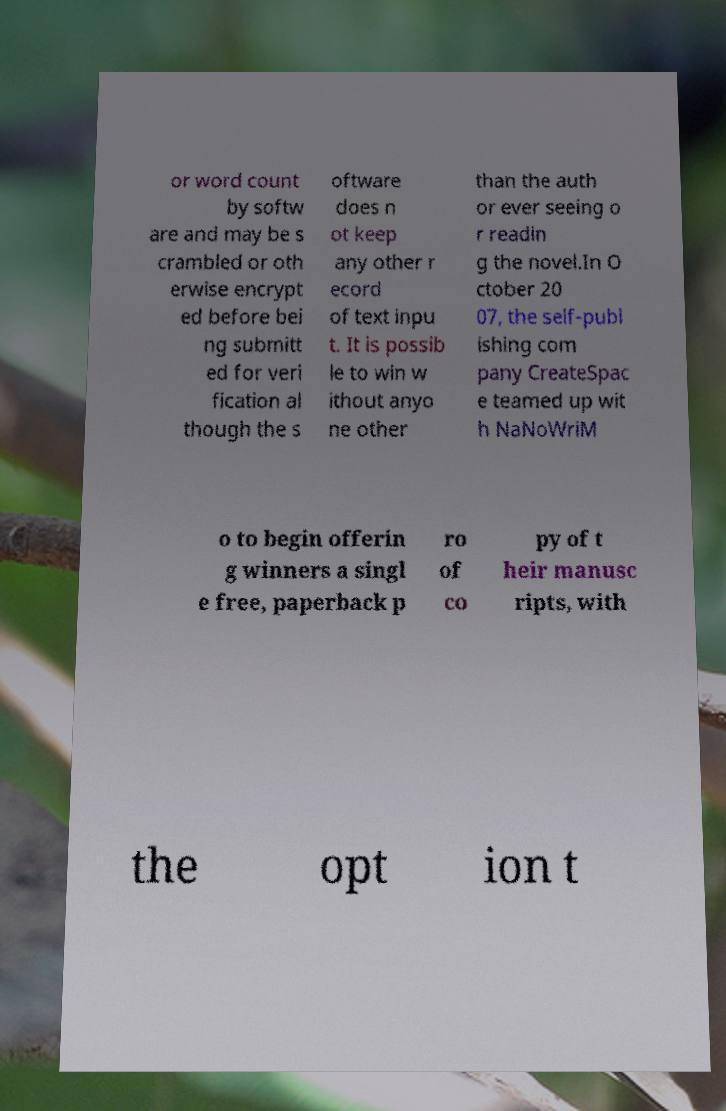What messages or text are displayed in this image? I need them in a readable, typed format. or word count by softw are and may be s crambled or oth erwise encrypt ed before bei ng submitt ed for veri fication al though the s oftware does n ot keep any other r ecord of text inpu t. It is possib le to win w ithout anyo ne other than the auth or ever seeing o r readin g the novel.In O ctober 20 07, the self-publ ishing com pany CreateSpac e teamed up wit h NaNoWriM o to begin offerin g winners a singl e free, paperback p ro of co py of t heir manusc ripts, with the opt ion t 